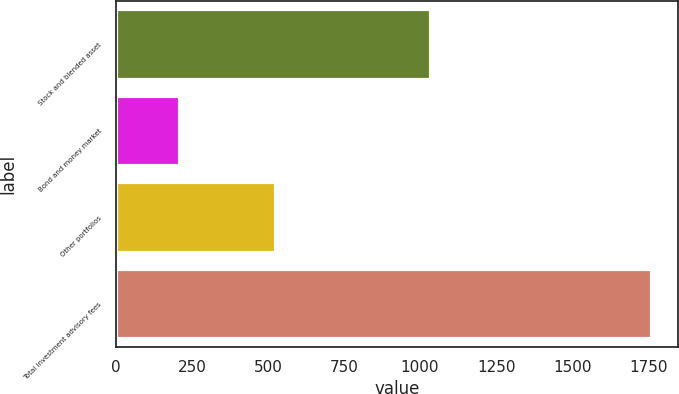<chart> <loc_0><loc_0><loc_500><loc_500><bar_chart><fcel>Stock and blended asset<fcel>Bond and money market<fcel>Other portfolios<fcel>Total investment advisory fees<nl><fcel>1031.4<fcel>207.4<fcel>522.2<fcel>1761<nl></chart> 